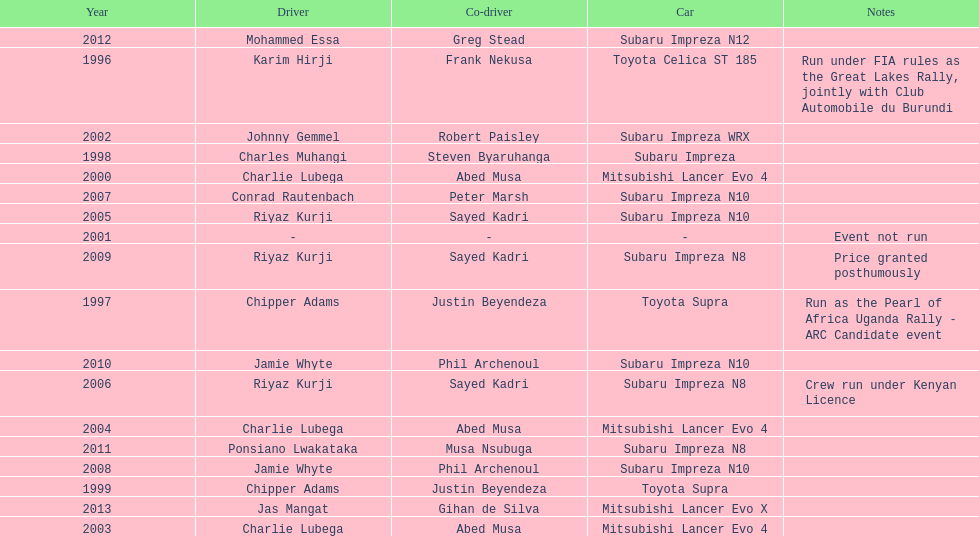Which was the only year that the event was not run? 2001. 